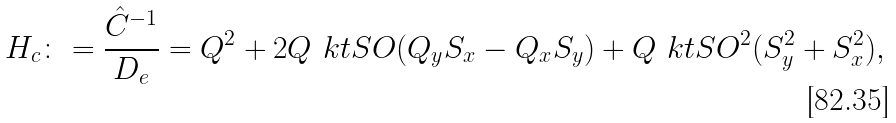Convert formula to latex. <formula><loc_0><loc_0><loc_500><loc_500>H _ { c } \colon = \frac { \hat { C } ^ { - 1 } } { D _ { e } } = { Q } ^ { 2 } + 2 Q _ { \ } k t { S O } ( Q _ { y } S _ { x } - Q _ { x } S _ { y } ) + Q _ { \ } k t { S O } ^ { 2 } ( S _ { y } ^ { 2 } + S _ { x } ^ { 2 } ) ,</formula> 